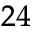<formula> <loc_0><loc_0><loc_500><loc_500>^ { 2 4 }</formula> 